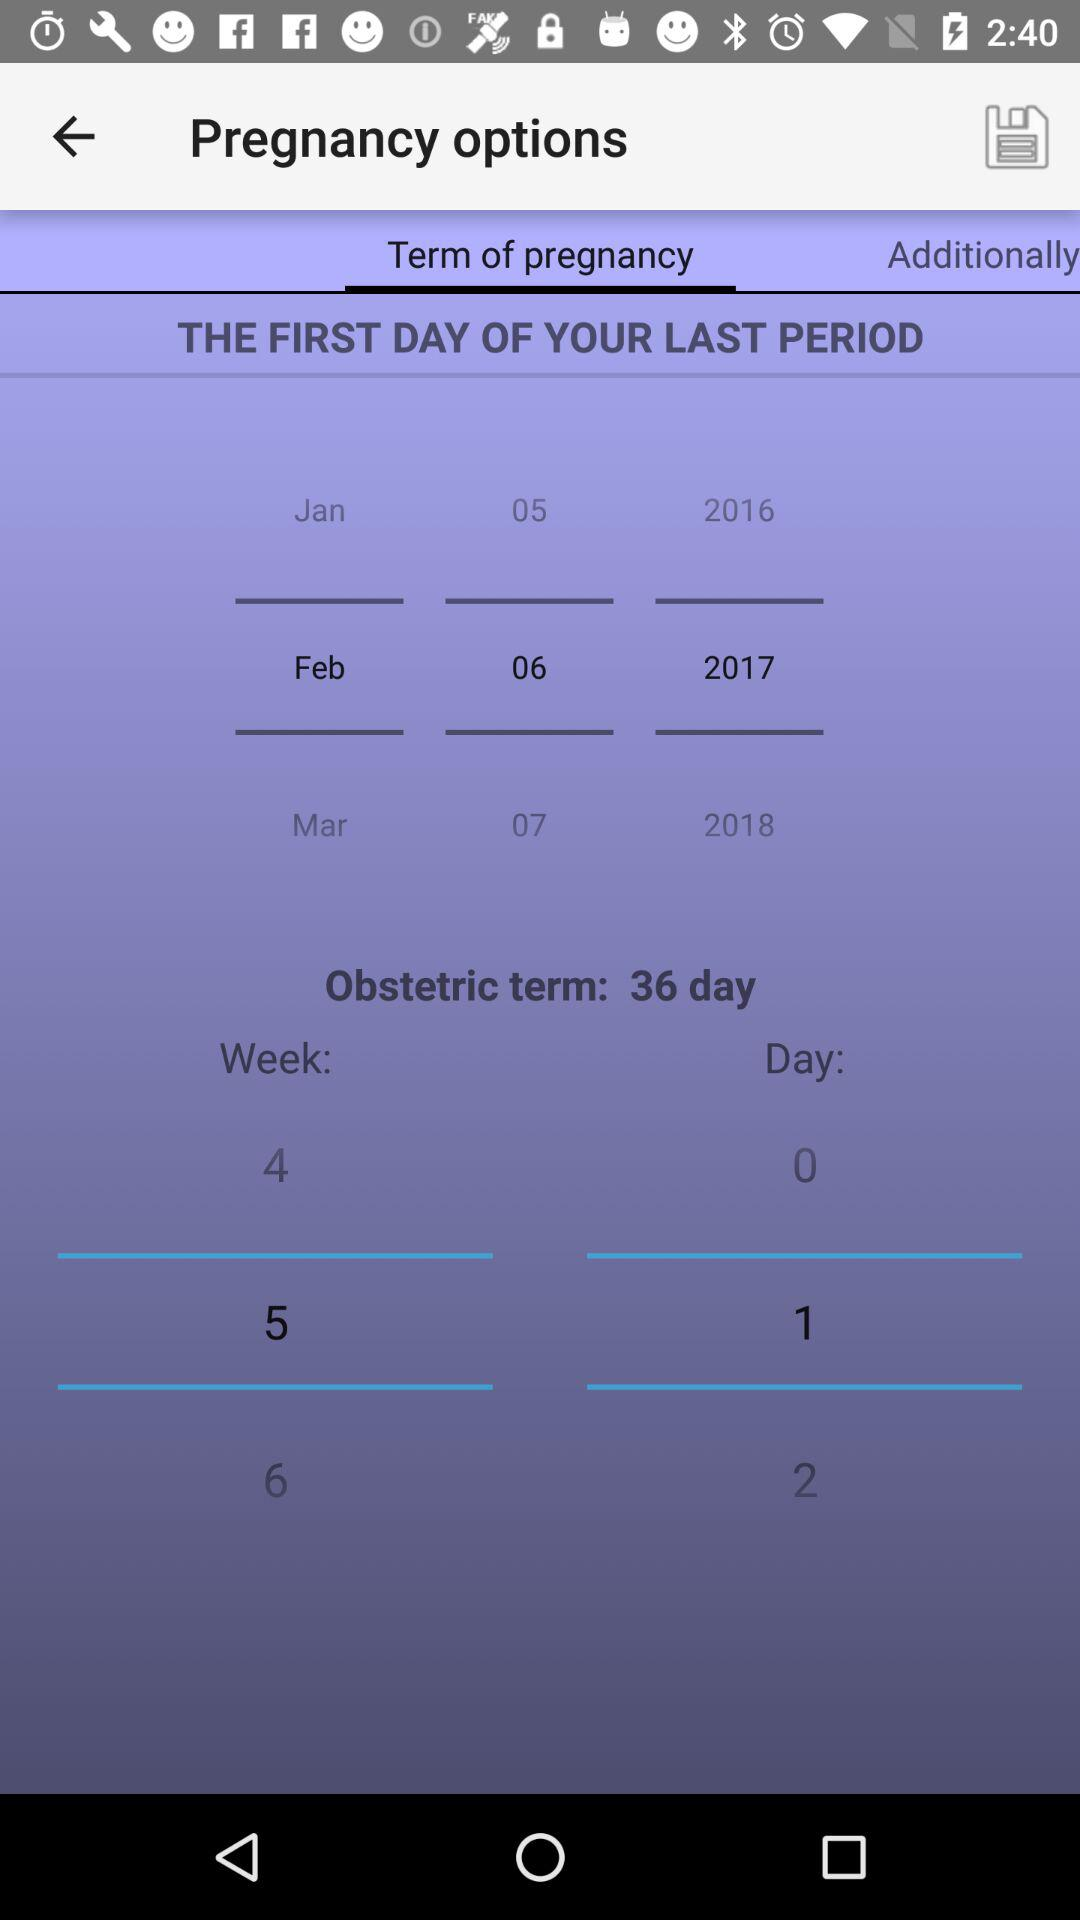Which option is selected for pregnancy? The selected option is "Term of pregnancy". 